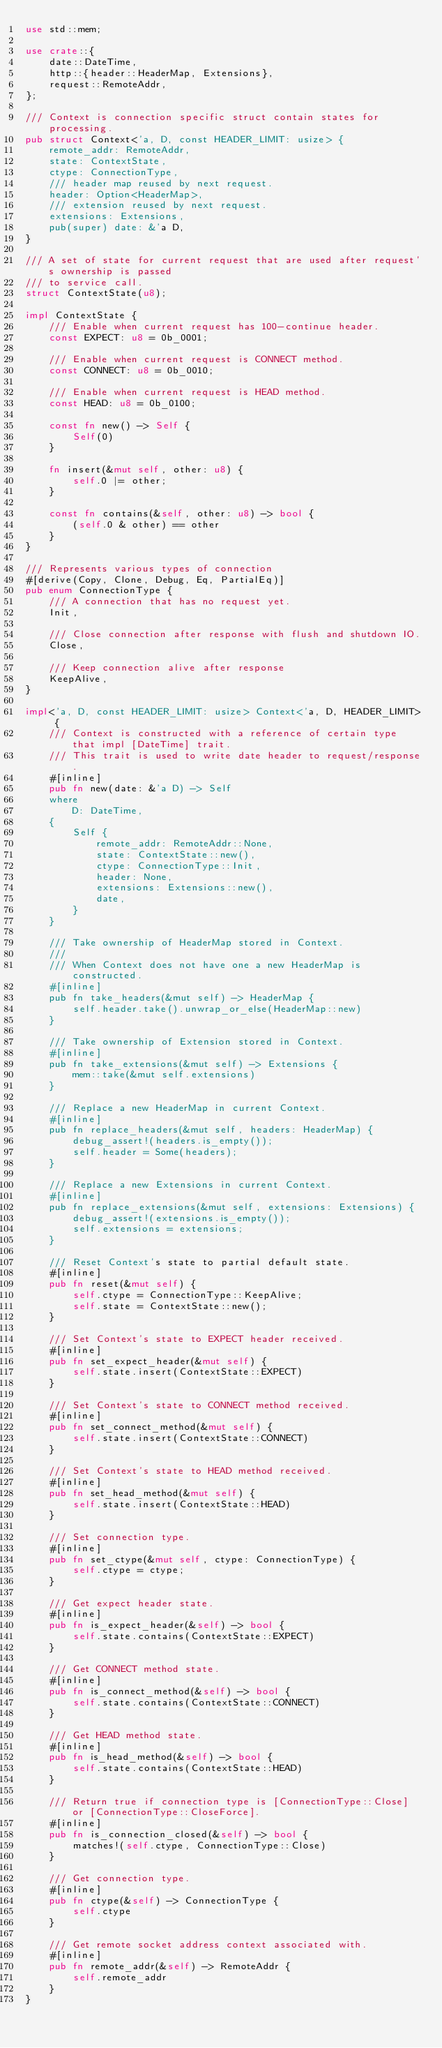<code> <loc_0><loc_0><loc_500><loc_500><_Rust_>use std::mem;

use crate::{
    date::DateTime,
    http::{header::HeaderMap, Extensions},
    request::RemoteAddr,
};

/// Context is connection specific struct contain states for processing.
pub struct Context<'a, D, const HEADER_LIMIT: usize> {
    remote_addr: RemoteAddr,
    state: ContextState,
    ctype: ConnectionType,
    /// header map reused by next request.
    header: Option<HeaderMap>,
    /// extension reused by next request.
    extensions: Extensions,
    pub(super) date: &'a D,
}

/// A set of state for current request that are used after request's ownership is passed
/// to service call.
struct ContextState(u8);

impl ContextState {
    /// Enable when current request has 100-continue header.
    const EXPECT: u8 = 0b_0001;

    /// Enable when current request is CONNECT method.
    const CONNECT: u8 = 0b_0010;

    /// Enable when current request is HEAD method.
    const HEAD: u8 = 0b_0100;

    const fn new() -> Self {
        Self(0)
    }

    fn insert(&mut self, other: u8) {
        self.0 |= other;
    }

    const fn contains(&self, other: u8) -> bool {
        (self.0 & other) == other
    }
}

/// Represents various types of connection
#[derive(Copy, Clone, Debug, Eq, PartialEq)]
pub enum ConnectionType {
    /// A connection that has no request yet.
    Init,

    /// Close connection after response with flush and shutdown IO.
    Close,

    /// Keep connection alive after response
    KeepAlive,
}

impl<'a, D, const HEADER_LIMIT: usize> Context<'a, D, HEADER_LIMIT> {
    /// Context is constructed with a reference of certain type that impl [DateTime] trait.
    /// This trait is used to write date header to request/response.
    #[inline]
    pub fn new(date: &'a D) -> Self
    where
        D: DateTime,
    {
        Self {
            remote_addr: RemoteAddr::None,
            state: ContextState::new(),
            ctype: ConnectionType::Init,
            header: None,
            extensions: Extensions::new(),
            date,
        }
    }

    /// Take ownership of HeaderMap stored in Context.
    ///
    /// When Context does not have one a new HeaderMap is constructed.
    #[inline]
    pub fn take_headers(&mut self) -> HeaderMap {
        self.header.take().unwrap_or_else(HeaderMap::new)
    }

    /// Take ownership of Extension stored in Context.
    #[inline]
    pub fn take_extensions(&mut self) -> Extensions {
        mem::take(&mut self.extensions)
    }

    /// Replace a new HeaderMap in current Context.
    #[inline]
    pub fn replace_headers(&mut self, headers: HeaderMap) {
        debug_assert!(headers.is_empty());
        self.header = Some(headers);
    }

    /// Replace a new Extensions in current Context.
    #[inline]
    pub fn replace_extensions(&mut self, extensions: Extensions) {
        debug_assert!(extensions.is_empty());
        self.extensions = extensions;
    }

    /// Reset Context's state to partial default state.
    #[inline]
    pub fn reset(&mut self) {
        self.ctype = ConnectionType::KeepAlive;
        self.state = ContextState::new();
    }

    /// Set Context's state to EXPECT header received.
    #[inline]
    pub fn set_expect_header(&mut self) {
        self.state.insert(ContextState::EXPECT)
    }

    /// Set Context's state to CONNECT method received.
    #[inline]
    pub fn set_connect_method(&mut self) {
        self.state.insert(ContextState::CONNECT)
    }

    /// Set Context's state to HEAD method received.
    #[inline]
    pub fn set_head_method(&mut self) {
        self.state.insert(ContextState::HEAD)
    }

    /// Set connection type.
    #[inline]
    pub fn set_ctype(&mut self, ctype: ConnectionType) {
        self.ctype = ctype;
    }

    /// Get expect header state.
    #[inline]
    pub fn is_expect_header(&self) -> bool {
        self.state.contains(ContextState::EXPECT)
    }

    /// Get CONNECT method state.
    #[inline]
    pub fn is_connect_method(&self) -> bool {
        self.state.contains(ContextState::CONNECT)
    }

    /// Get HEAD method state.
    #[inline]
    pub fn is_head_method(&self) -> bool {
        self.state.contains(ContextState::HEAD)
    }

    /// Return true if connection type is [ConnectionType::Close] or [ConnectionType::CloseForce].
    #[inline]
    pub fn is_connection_closed(&self) -> bool {
        matches!(self.ctype, ConnectionType::Close)
    }

    /// Get connection type.
    #[inline]
    pub fn ctype(&self) -> ConnectionType {
        self.ctype
    }

    /// Get remote socket address context associated with.
    #[inline]
    pub fn remote_addr(&self) -> RemoteAddr {
        self.remote_addr
    }
}
</code> 